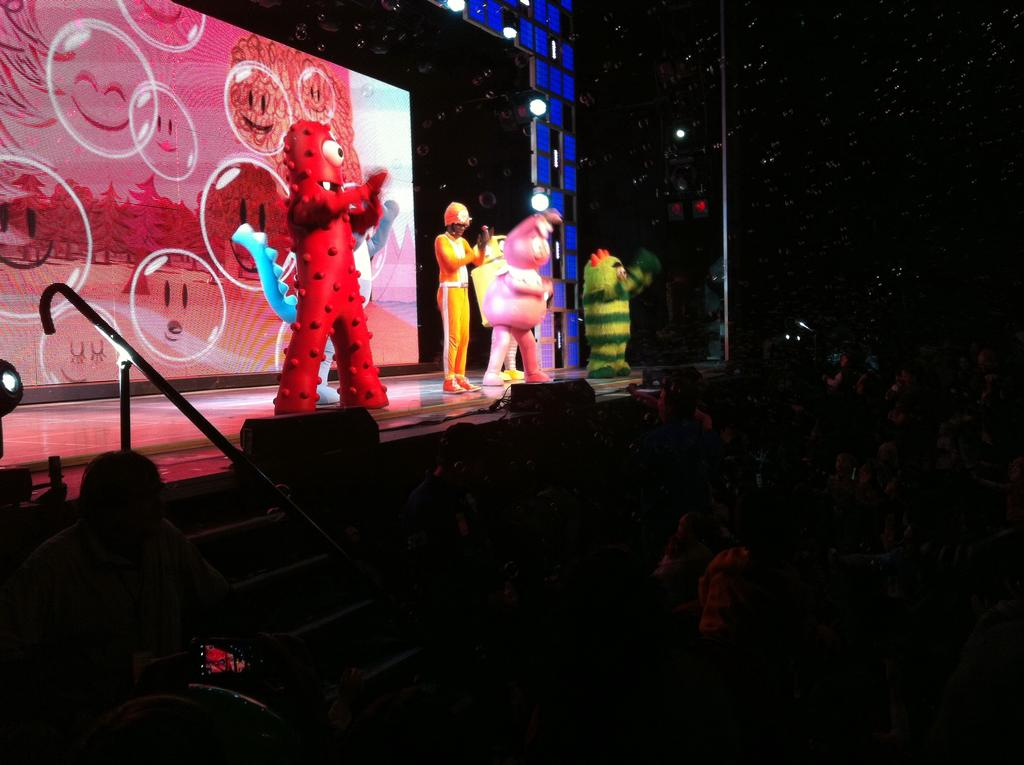What type of structure can be seen in the image? There is a wall in the image. What feature allows natural light to enter the space? There are skylights in the image. Who or what is present in the image? There are people in the image. What architectural element is visible in the image? There are stairs in the image. How would you describe the lighting in the image? The image is dark. What type of ear is visible on the wall in the image? There is no ear present on the wall in the image. What kind of error can be seen in the image? There is no error visible in the image. 